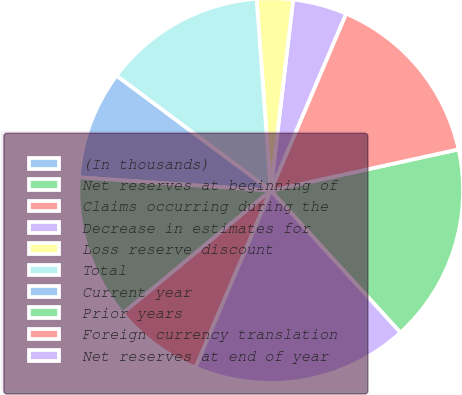Convert chart to OTSL. <chart><loc_0><loc_0><loc_500><loc_500><pie_chart><fcel>(In thousands)<fcel>Net reserves at beginning of<fcel>Claims occurring during the<fcel>Decrease in estimates for<fcel>Loss reserve discount<fcel>Total<fcel>Current year<fcel>Prior years<fcel>Foreign currency translation<fcel>Net reserves at end of year<nl><fcel>0.0%<fcel>16.66%<fcel>15.15%<fcel>4.55%<fcel>3.03%<fcel>13.64%<fcel>9.09%<fcel>12.12%<fcel>7.58%<fcel>18.18%<nl></chart> 